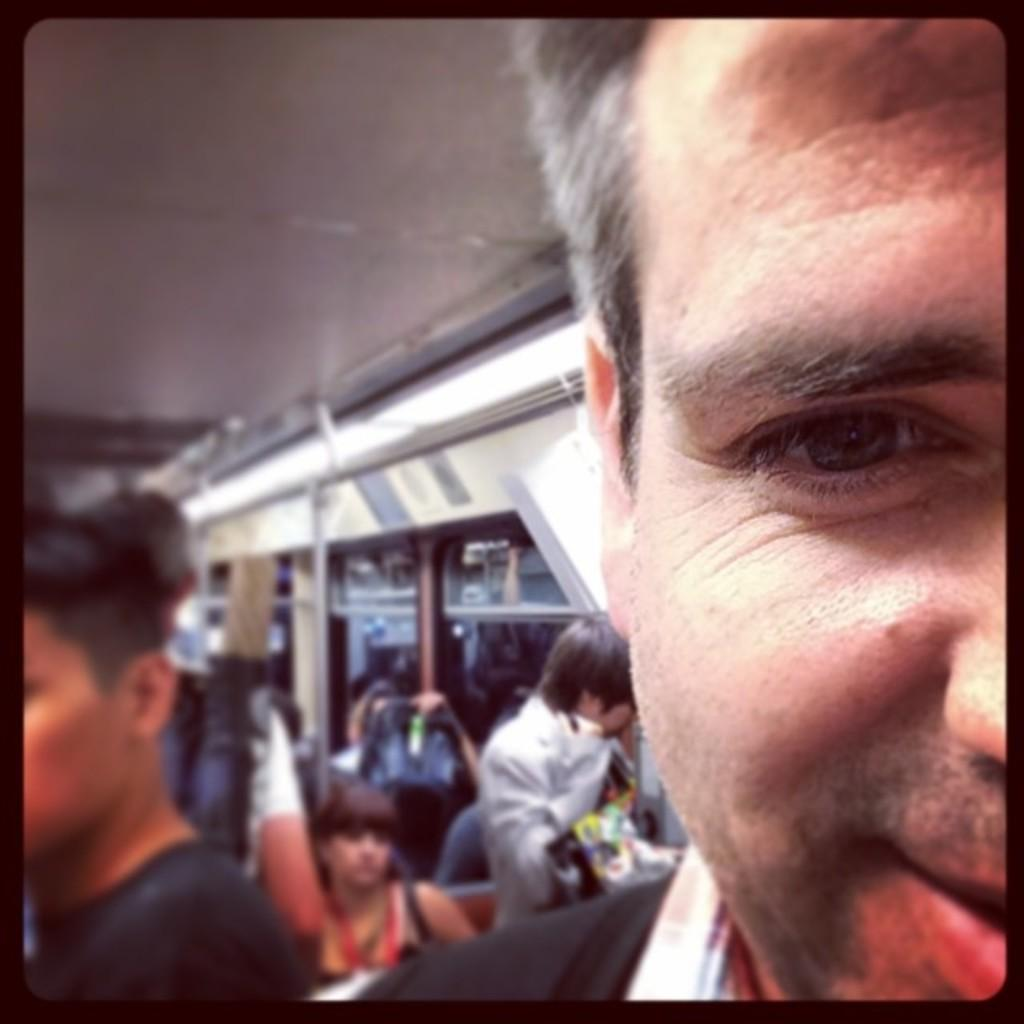What is the main action being performed by the person in the image? The person in the image is taking a selfie. Can you describe the surroundings of the person taking the selfie? There are other people visible in the background of the image. What is the context or setting of the image? The location appears to be related to a vehicle. What type of wool can be seen in the image? There is no wool present in the image. What is the texture of the mine in the image? There is no mine present in the image. 